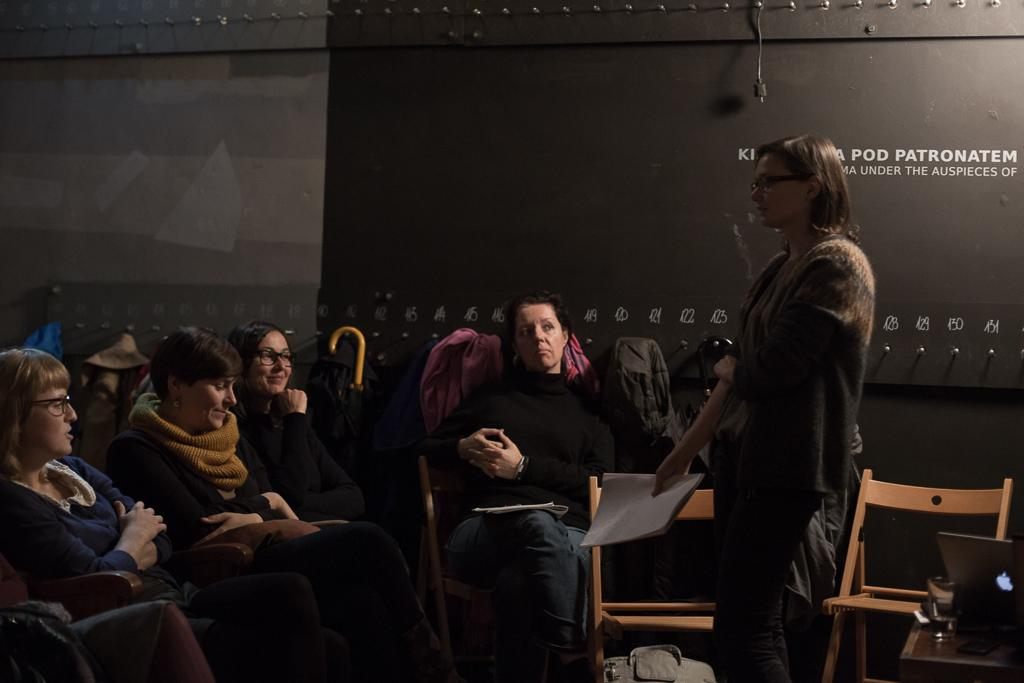How many women are present in the image? There are four women in the image. What are the four women doing? The four women are listening to another woman. Where is the other woman standing in relation to the four women? The other woman is standing in front of them. What is the other woman holding? The other woman is holding some papers. What is the uncle doing in the middle of the image? There is no uncle present in the image. What type of ground can be seen in the image? The image does not show any ground; it appears to be an indoor setting. 